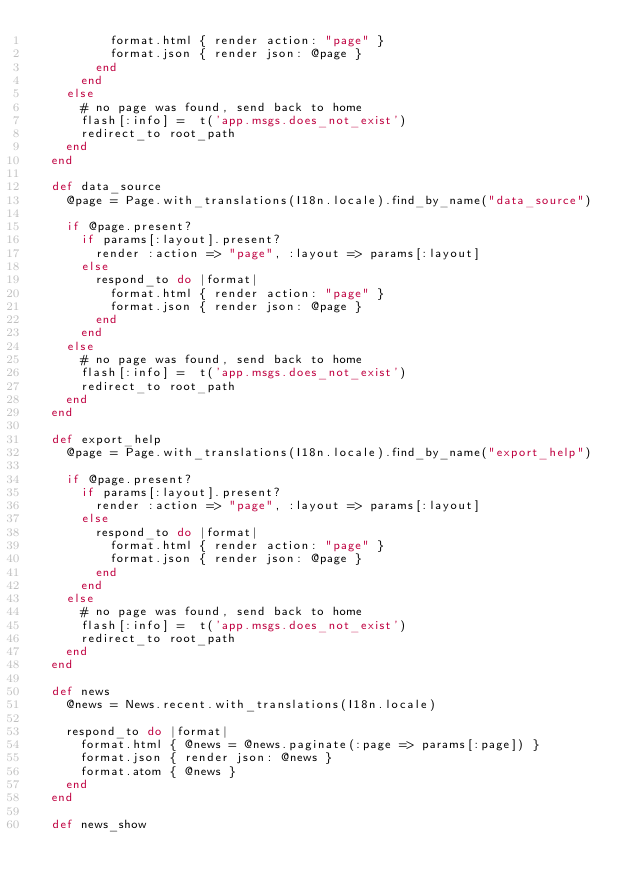Convert code to text. <code><loc_0><loc_0><loc_500><loc_500><_Ruby_>		      format.html { render action: "page" }
		      format.json { render json: @page }
		    end
			end
		else
			# no page was found, send back to home
			flash[:info] =  t('app.msgs.does_not_exist')
			redirect_to root_path
		end
  end

  def data_source
    @page = Page.with_translations(I18n.locale).find_by_name("data_source")

		if @page.present?
		  if params[:layout].present?
				render :action => "page", :layout => params[:layout]
		  else
		    respond_to do |format|
		      format.html { render action: "page" }
		      format.json { render json: @page }
		    end
			end
		else
			# no page was found, send back to home
			flash[:info] =  t('app.msgs.does_not_exist')
			redirect_to root_path
		end
  end

  def export_help
    @page = Page.with_translations(I18n.locale).find_by_name("export_help")

		if @page.present?
		  if params[:layout].present?
				render :action => "page", :layout => params[:layout]
		  else
		    respond_to do |format|
		      format.html { render action: "page" }
		      format.json { render json: @page }
		    end
			end
		else
			# no page was found, send back to home
			flash[:info] =  t('app.msgs.does_not_exist')
			redirect_to root_path
		end
  end

  def news
    @news = News.recent.with_translations(I18n.locale)

    respond_to do |format|
      format.html { @news = @news.paginate(:page => params[:page]) }
      format.json { render json: @news }
      format.atom { @news }
    end
  end

  def news_show</code> 